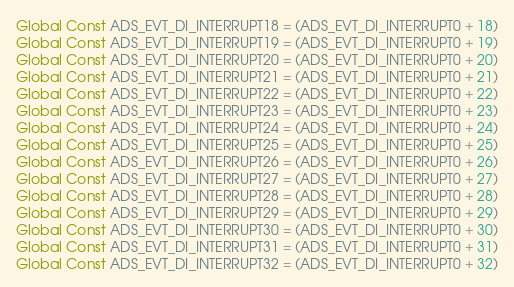<code> <loc_0><loc_0><loc_500><loc_500><_VisualBasic_>Global Const ADS_EVT_DI_INTERRUPT18 = (ADS_EVT_DI_INTERRUPT0 + 18)
Global Const ADS_EVT_DI_INTERRUPT19 = (ADS_EVT_DI_INTERRUPT0 + 19)
Global Const ADS_EVT_DI_INTERRUPT20 = (ADS_EVT_DI_INTERRUPT0 + 20)
Global Const ADS_EVT_DI_INTERRUPT21 = (ADS_EVT_DI_INTERRUPT0 + 21)
Global Const ADS_EVT_DI_INTERRUPT22 = (ADS_EVT_DI_INTERRUPT0 + 22)
Global Const ADS_EVT_DI_INTERRUPT23 = (ADS_EVT_DI_INTERRUPT0 + 23)
Global Const ADS_EVT_DI_INTERRUPT24 = (ADS_EVT_DI_INTERRUPT0 + 24)
Global Const ADS_EVT_DI_INTERRUPT25 = (ADS_EVT_DI_INTERRUPT0 + 25)
Global Const ADS_EVT_DI_INTERRUPT26 = (ADS_EVT_DI_INTERRUPT0 + 26)
Global Const ADS_EVT_DI_INTERRUPT27 = (ADS_EVT_DI_INTERRUPT0 + 27)
Global Const ADS_EVT_DI_INTERRUPT28 = (ADS_EVT_DI_INTERRUPT0 + 28)
Global Const ADS_EVT_DI_INTERRUPT29 = (ADS_EVT_DI_INTERRUPT0 + 29)
Global Const ADS_EVT_DI_INTERRUPT30 = (ADS_EVT_DI_INTERRUPT0 + 30)
Global Const ADS_EVT_DI_INTERRUPT31 = (ADS_EVT_DI_INTERRUPT0 + 31)
Global Const ADS_EVT_DI_INTERRUPT32 = (ADS_EVT_DI_INTERRUPT0 + 32)</code> 